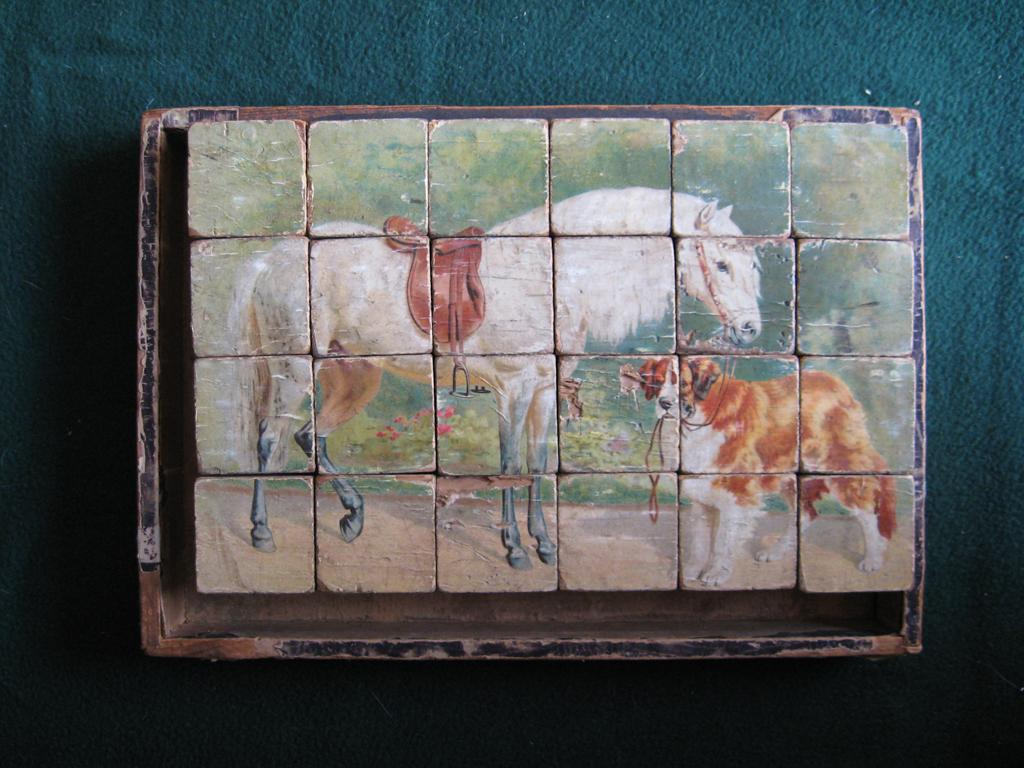What is the main subject of the painting in the image? The painting depicts a dog and a horse. How is the painting displayed in the image? The painting is on blocks, which are placed on a frame. Where is the frame located in the image? The frame is kept on a surface. How many ladybugs can be seen on the horse in the painting? There are no ladybugs present in the painting; it depicts a dog and a horse. What type of can is used to store the paint for the painting? There is no information about the paint or the can used to store it in the image. 